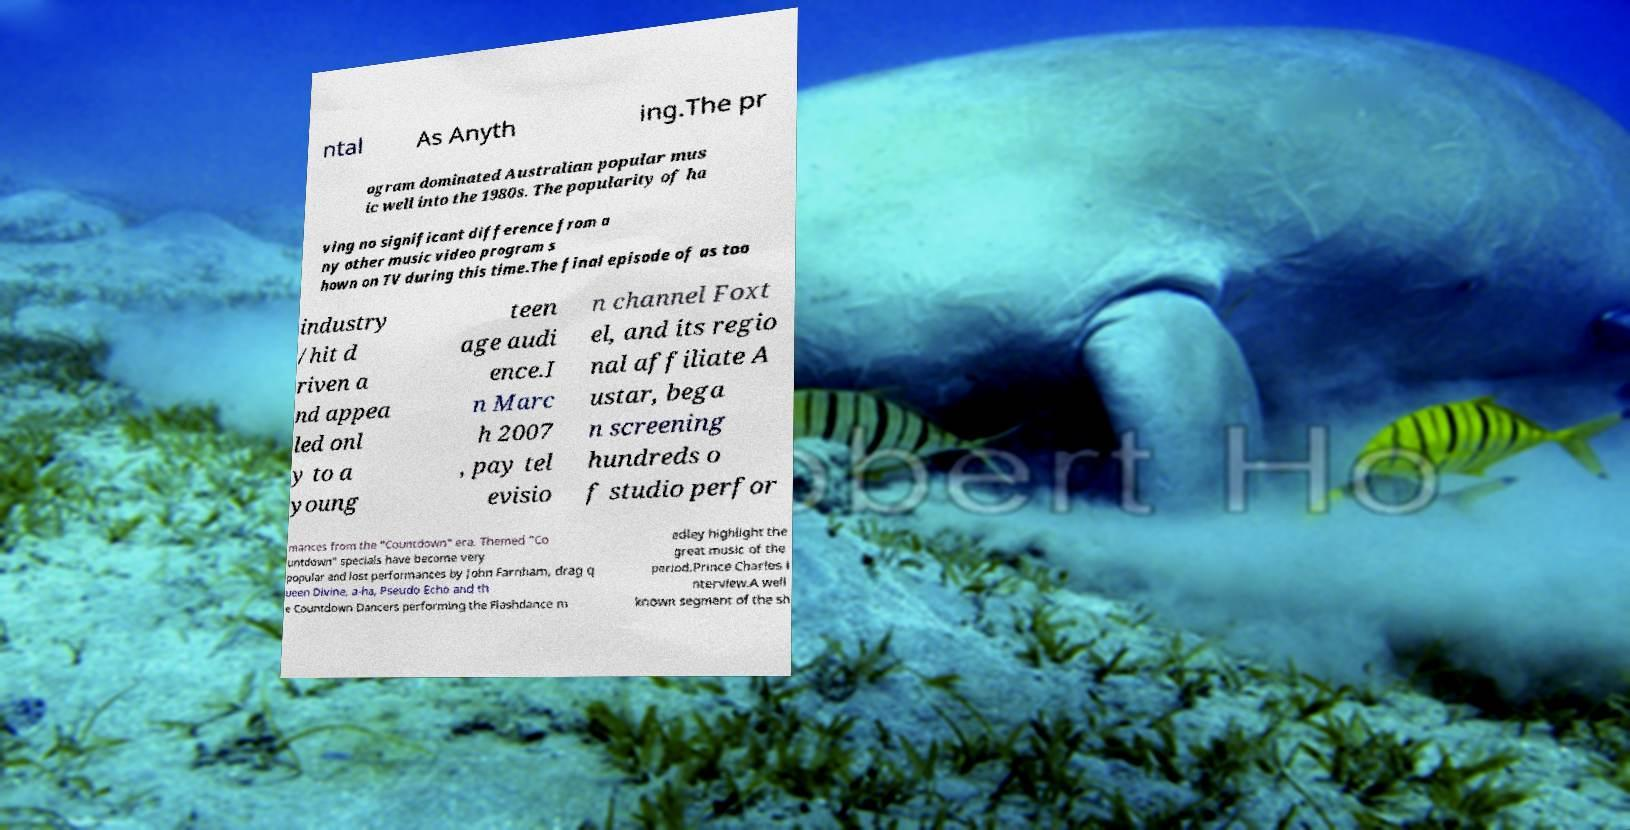Can you read and provide the text displayed in the image?This photo seems to have some interesting text. Can you extract and type it out for me? ntal As Anyth ing.The pr ogram dominated Australian popular mus ic well into the 1980s. The popularity of ha ving no significant difference from a ny other music video program s hown on TV during this time.The final episode of as too industry /hit d riven a nd appea led onl y to a young teen age audi ence.I n Marc h 2007 , pay tel evisio n channel Foxt el, and its regio nal affiliate A ustar, bega n screening hundreds o f studio perfor mances from the "Countdown" era. Themed "Co untdown" specials have become very popular and lost performances by John Farnham, drag q ueen Divine, a-ha, Pseudo Echo and th e Countdown Dancers performing the Flashdance m edley highlight the great music of the period.Prince Charles i nterview.A well known segment of the sh 